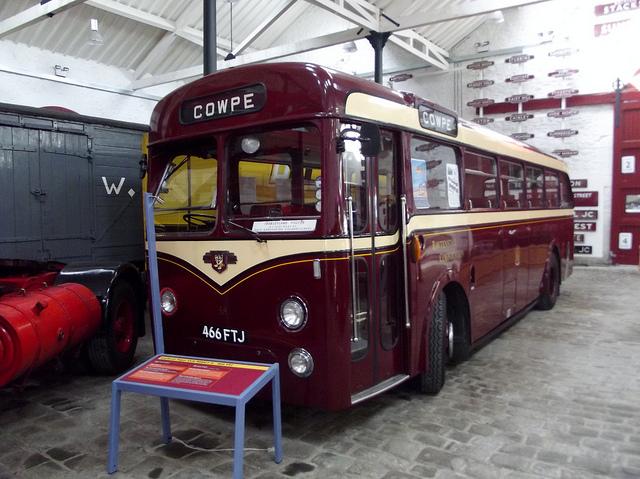Is the closest bus in motion?
Give a very brief answer. No. What color is the bus?
Keep it brief. Maroon. What is in front of the bus?
Concise answer only. Table. What is the bus number?
Keep it brief. 466. 